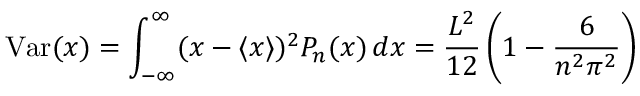Convert formula to latex. <formula><loc_0><loc_0><loc_500><loc_500>V a r ( x ) = \int _ { - \infty } ^ { \infty } ( x - \langle x \rangle ) ^ { 2 } P _ { n } ( x ) \, d x = { \frac { L ^ { 2 } } { 1 2 } } \left ( 1 - { \frac { 6 } { n ^ { 2 } \pi ^ { 2 } } } \right )</formula> 